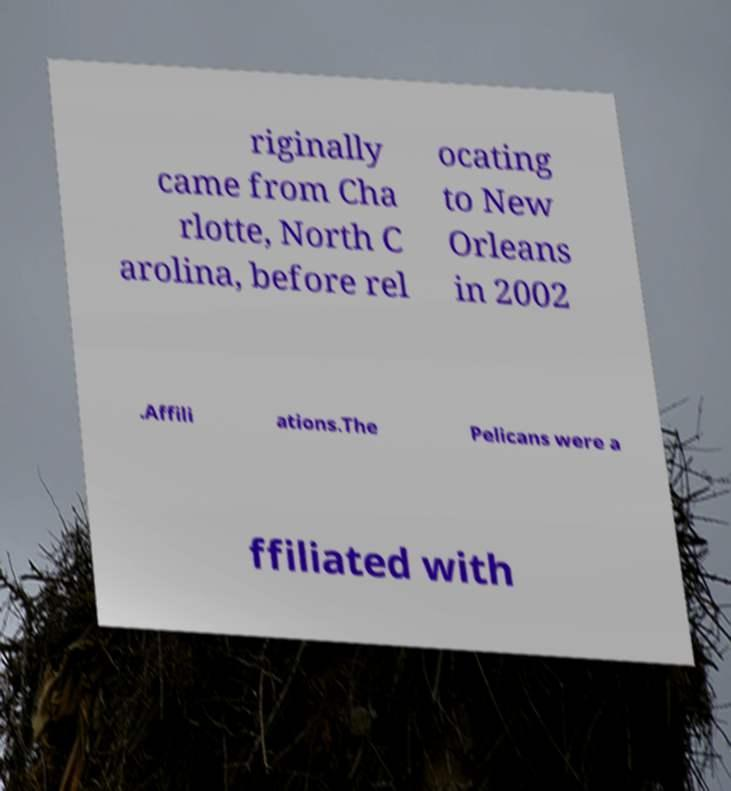What messages or text are displayed in this image? I need them in a readable, typed format. riginally came from Cha rlotte, North C arolina, before rel ocating to New Orleans in 2002 .Affili ations.The Pelicans were a ffiliated with 